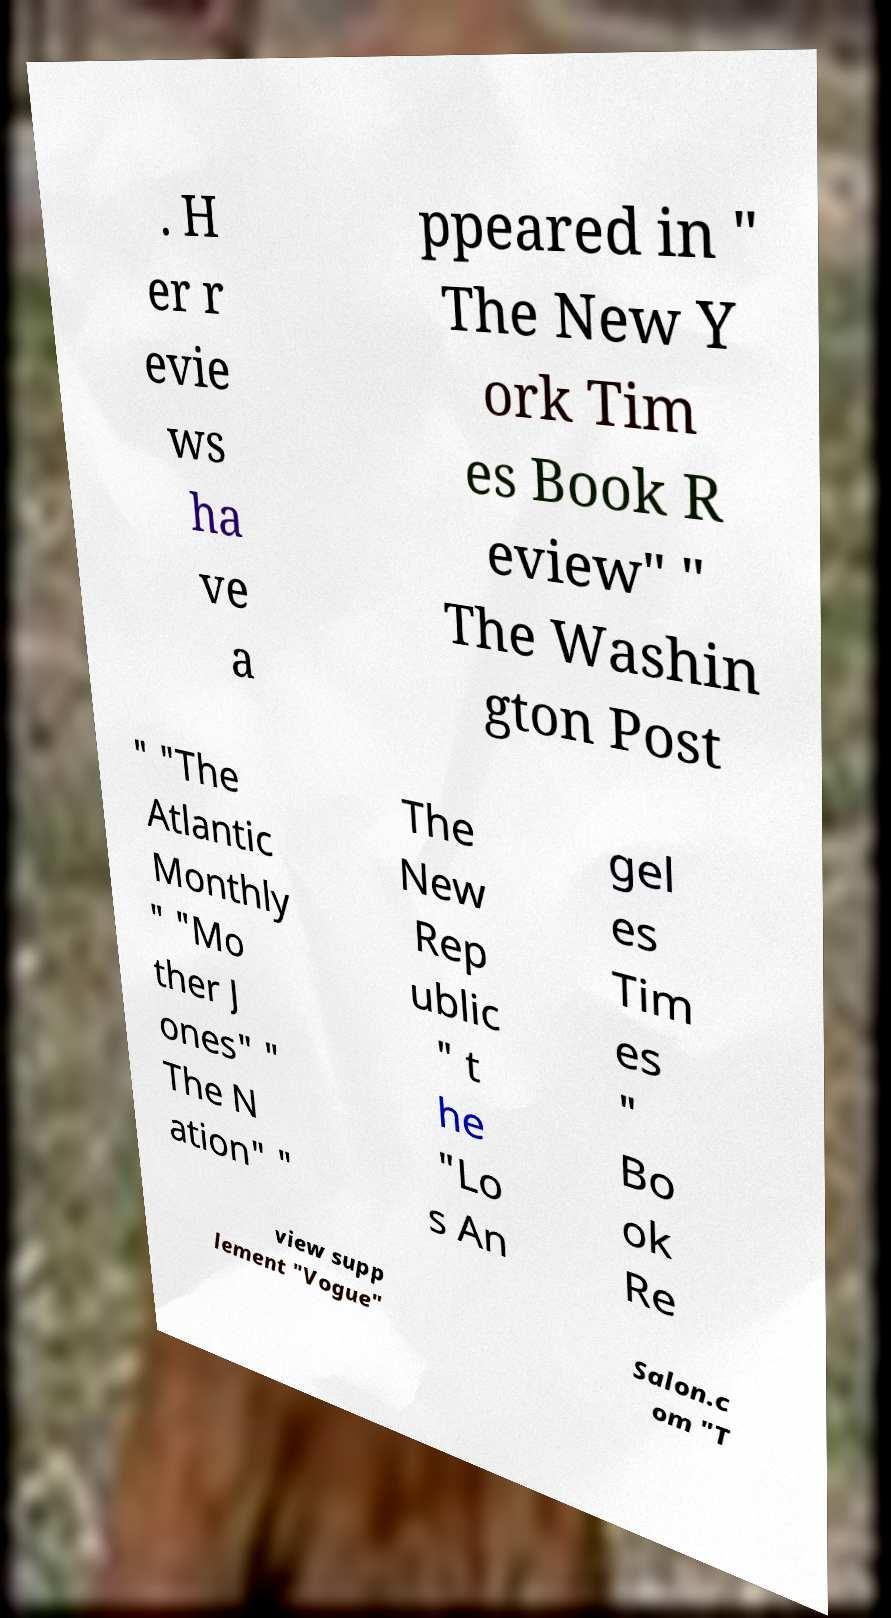For documentation purposes, I need the text within this image transcribed. Could you provide that? . H er r evie ws ha ve a ppeared in " The New Y ork Tim es Book R eview" " The Washin gton Post " "The Atlantic Monthly " "Mo ther J ones" " The N ation" " The New Rep ublic " t he "Lo s An gel es Tim es " Bo ok Re view supp lement "Vogue" Salon.c om "T 